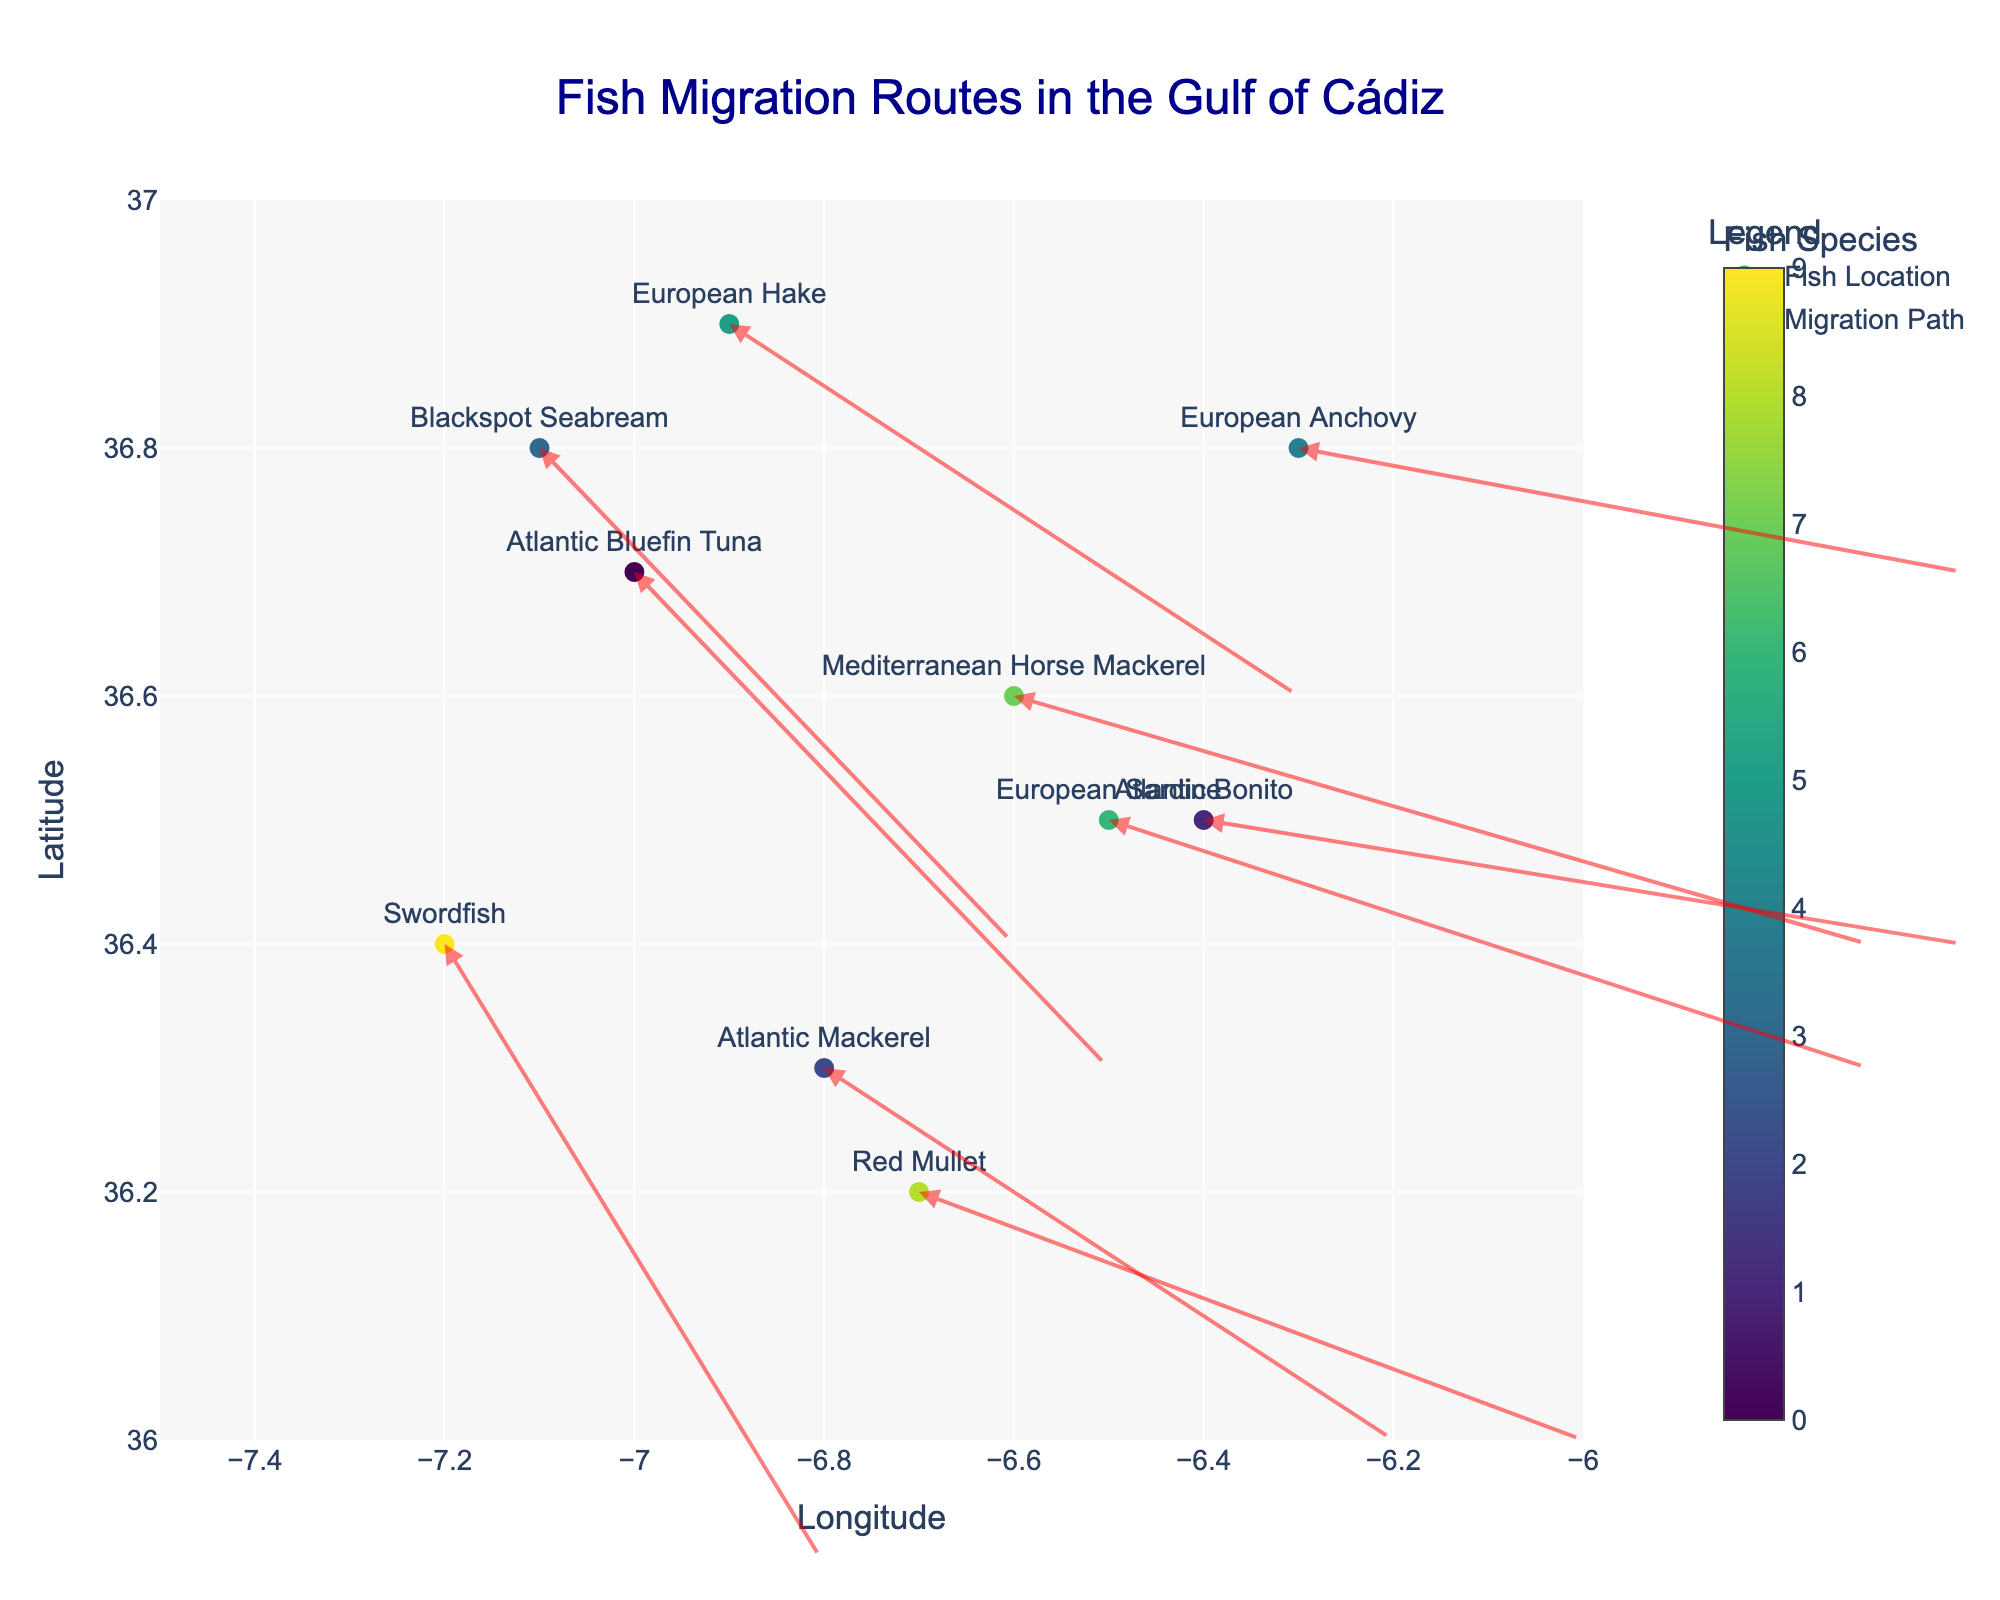What's the title of the plot? The title of the plot is usually located at the top center of the figure. In this figure, it reads "Fish Migration Routes in the Gulf of Cádiz".
Answer: Fish Migration Routes in the Gulf of Cádiz What do the colors in the markers represent? The color of each marker corresponds to different fish species. The figure's colorbar, which is labeled "Fish Species," indicates this relationship.
Answer: Fish species How many fish species' migration routes are shown in the plot? Each marker represents a distinct fish species. By counting the unique species labels displayed next to each marker, we find there are 10 species mentioned.
Answer: 10 Which species has the longest migration distance in this figure? To determine this, one must look at the arrow lengths. The longest arrow corresponds to the vector with the greatest magnitude. By visually inspecting the figure, the vector for the Mediterranean Horse Mackerel appears to be the longest.
Answer: Mediterranean Horse Mackerel Which fish species is located at (-6.8, 36.3)? Locate the marker positioned at the coordinates (-6.8, 36.3) and check its label. The label shows that it's the Atlantic Mackerel.
Answer: Atlantic Mackerel Which fish has the least negative change in latitude (v value)? Compare the vectors' vertical component (v). The least negative implies closest to zero but still negative. The European Anchovy has the least negative value of v = -0.1.
Answer: European Anchovy How does the migration direction of the Atlantic Bluefin Tuna compare to that of the Swordfish? Look at the vectors for both species. Both the Atlantic Bluefin Tuna and Swordfish have vectors pointing southeast, but the Swordfish has a steeper downward angle, making its vector longer.
Answer: Both are southeast, but Swordfish has a steeper angle Which two fish species have the same migration speed (same magnitude of u and v)? By comparing the magnitudes of the u and v components, European Hake (u=0.6, v=-0.3) and Atlantic Mackerel (u=0.6, v=-0.3) have the same migration speeds.
Answer: European Hake and Atlantic Mackerel 